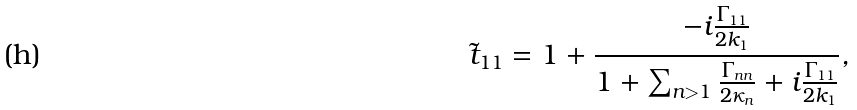<formula> <loc_0><loc_0><loc_500><loc_500>\tilde { t } _ { 1 1 } = 1 + \frac { - i \frac { \Gamma _ { 1 1 } } { 2 k _ { 1 } } } { 1 + \sum _ { n > 1 } \frac { \Gamma _ { n n } } { 2 \kappa _ { n } } + i \frac { \Gamma _ { 1 1 } } { 2 k _ { 1 } } } ,</formula> 